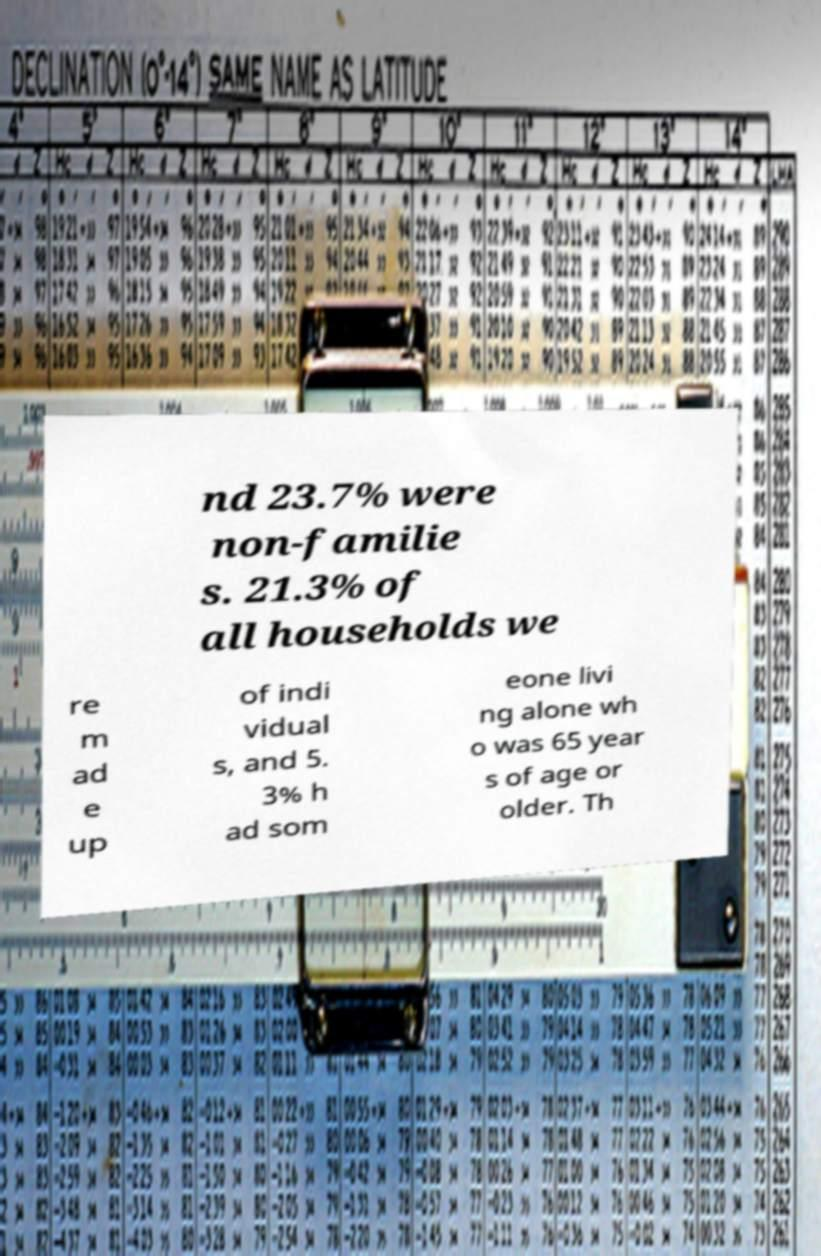Please identify and transcribe the text found in this image. nd 23.7% were non-familie s. 21.3% of all households we re m ad e up of indi vidual s, and 5. 3% h ad som eone livi ng alone wh o was 65 year s of age or older. Th 